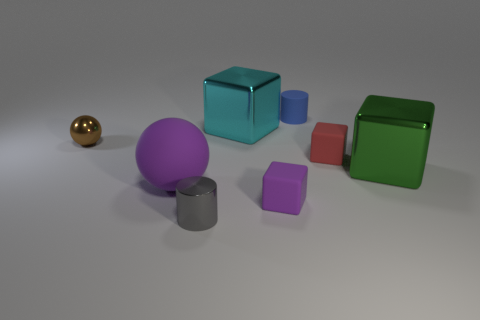Subtract all green cubes. How many cubes are left? 3 Add 1 small gray metallic things. How many objects exist? 9 Subtract all green spheres. Subtract all brown cubes. How many spheres are left? 2 Subtract all yellow cylinders. How many brown spheres are left? 1 Subtract all small spheres. Subtract all tiny gray objects. How many objects are left? 6 Add 5 cyan cubes. How many cyan cubes are left? 6 Add 3 gray shiny cylinders. How many gray shiny cylinders exist? 4 Subtract all green blocks. How many blocks are left? 3 Subtract 0 cyan balls. How many objects are left? 8 Subtract all cylinders. How many objects are left? 6 